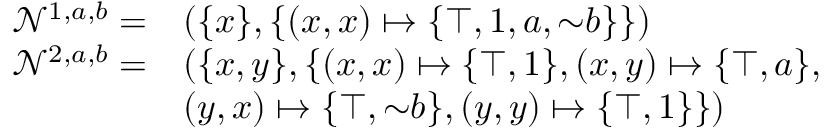<formula> <loc_0><loc_0><loc_500><loc_500>\begin{array} { r l } { \mathcal { N } ^ { 1 , a , b } = } & { ( \{ x \} , \{ ( x , x ) \mapsto \{ \top , 1 , a , { \sim } b \} \} ) } \\ { \mathcal { N } ^ { 2 , a , b } = } & { ( \{ x , y \} , \{ ( x , x ) \mapsto \{ \top , 1 \} , ( x , y ) \mapsto \{ \top , a \} , } \\ & { ( y , x ) \mapsto \{ \top , { \sim } b \} , ( y , y ) \mapsto \{ \top , 1 \} \} ) } \end{array}</formula> 